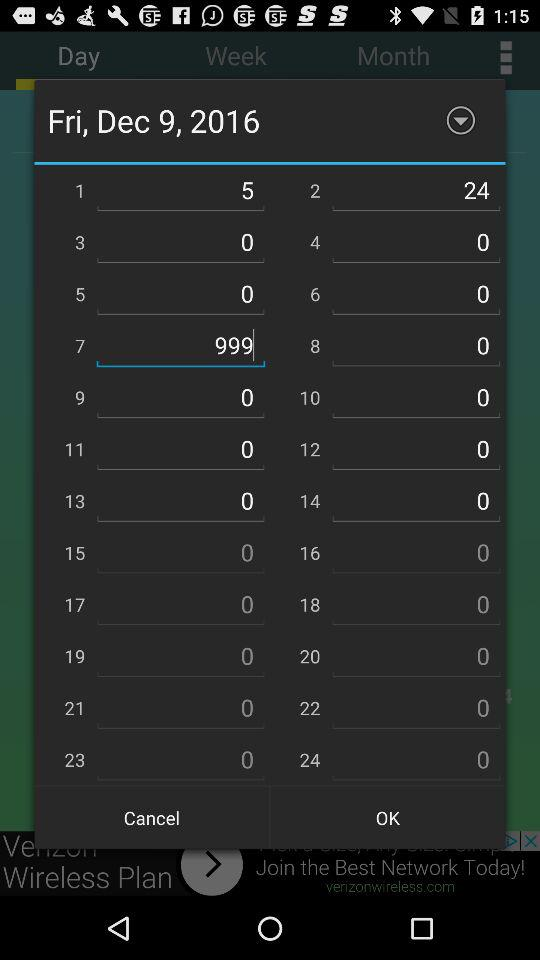What is the entered number? The entered number is 999. 